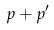Convert formula to latex. <formula><loc_0><loc_0><loc_500><loc_500>p + p ^ { \prime }</formula> 